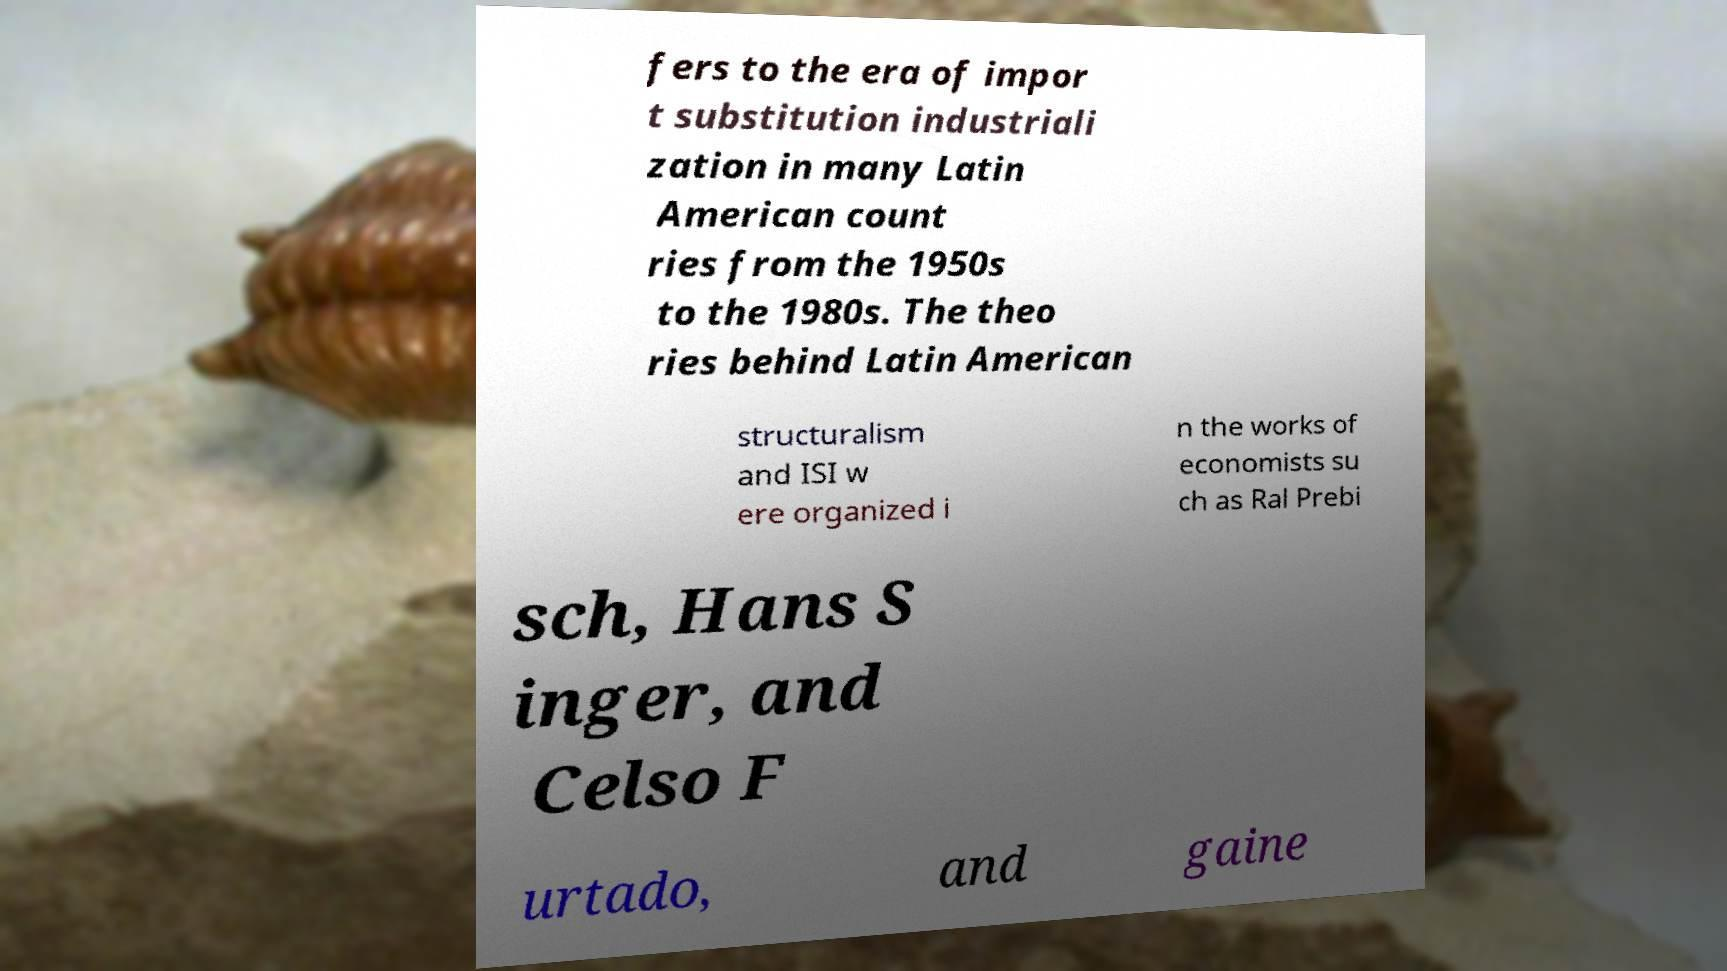There's text embedded in this image that I need extracted. Can you transcribe it verbatim? fers to the era of impor t substitution industriali zation in many Latin American count ries from the 1950s to the 1980s. The theo ries behind Latin American structuralism and ISI w ere organized i n the works of economists su ch as Ral Prebi sch, Hans S inger, and Celso F urtado, and gaine 